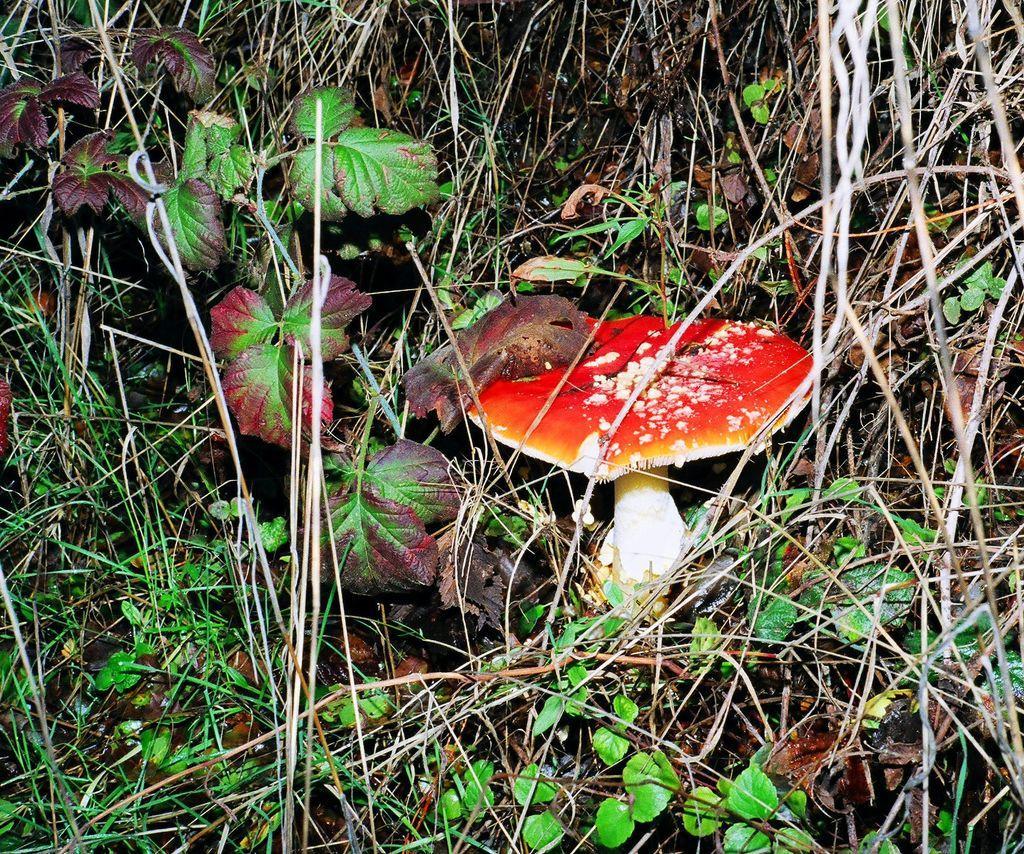Please provide a concise description of this image. In the foreground of this image, there is a mushroom, few plants and the grass. 